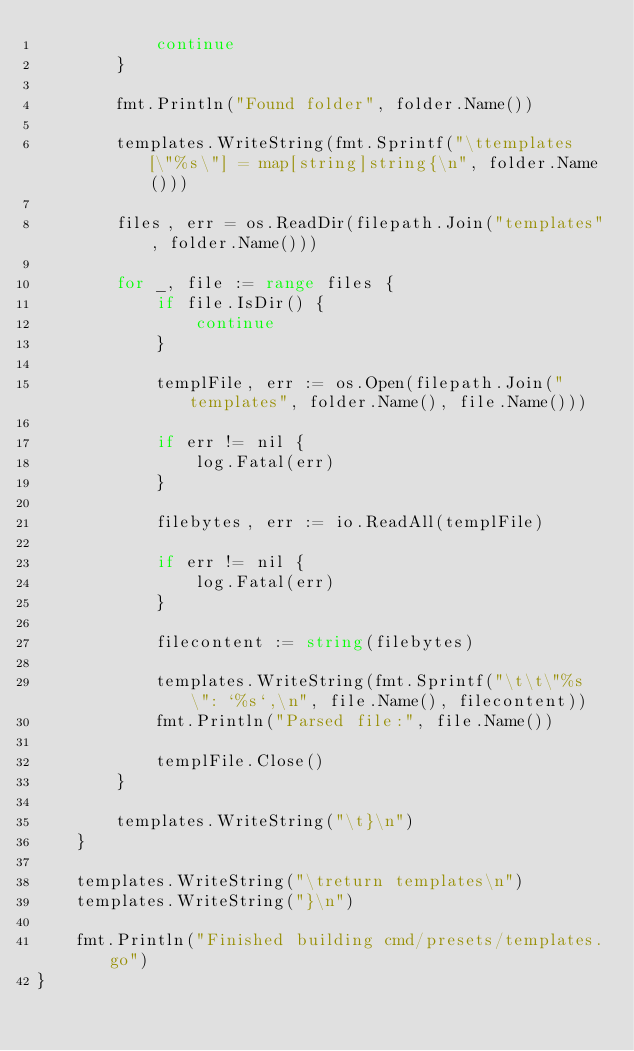<code> <loc_0><loc_0><loc_500><loc_500><_Go_>			continue
		}

		fmt.Println("Found folder", folder.Name())

		templates.WriteString(fmt.Sprintf("\ttemplates[\"%s\"] = map[string]string{\n", folder.Name()))

		files, err = os.ReadDir(filepath.Join("templates", folder.Name()))

		for _, file := range files {
			if file.IsDir() {
				continue
			}

			templFile, err := os.Open(filepath.Join("templates", folder.Name(), file.Name()))

			if err != nil {
				log.Fatal(err)
			}

			filebytes, err := io.ReadAll(templFile)

			if err != nil {
				log.Fatal(err)
			}

			filecontent := string(filebytes)

			templates.WriteString(fmt.Sprintf("\t\t\"%s\": `%s`,\n", file.Name(), filecontent))
			fmt.Println("Parsed file:", file.Name())

			templFile.Close()
		}

		templates.WriteString("\t}\n")
	}

	templates.WriteString("\treturn templates\n")
	templates.WriteString("}\n")

	fmt.Println("Finished building cmd/presets/templates.go")
}
</code> 